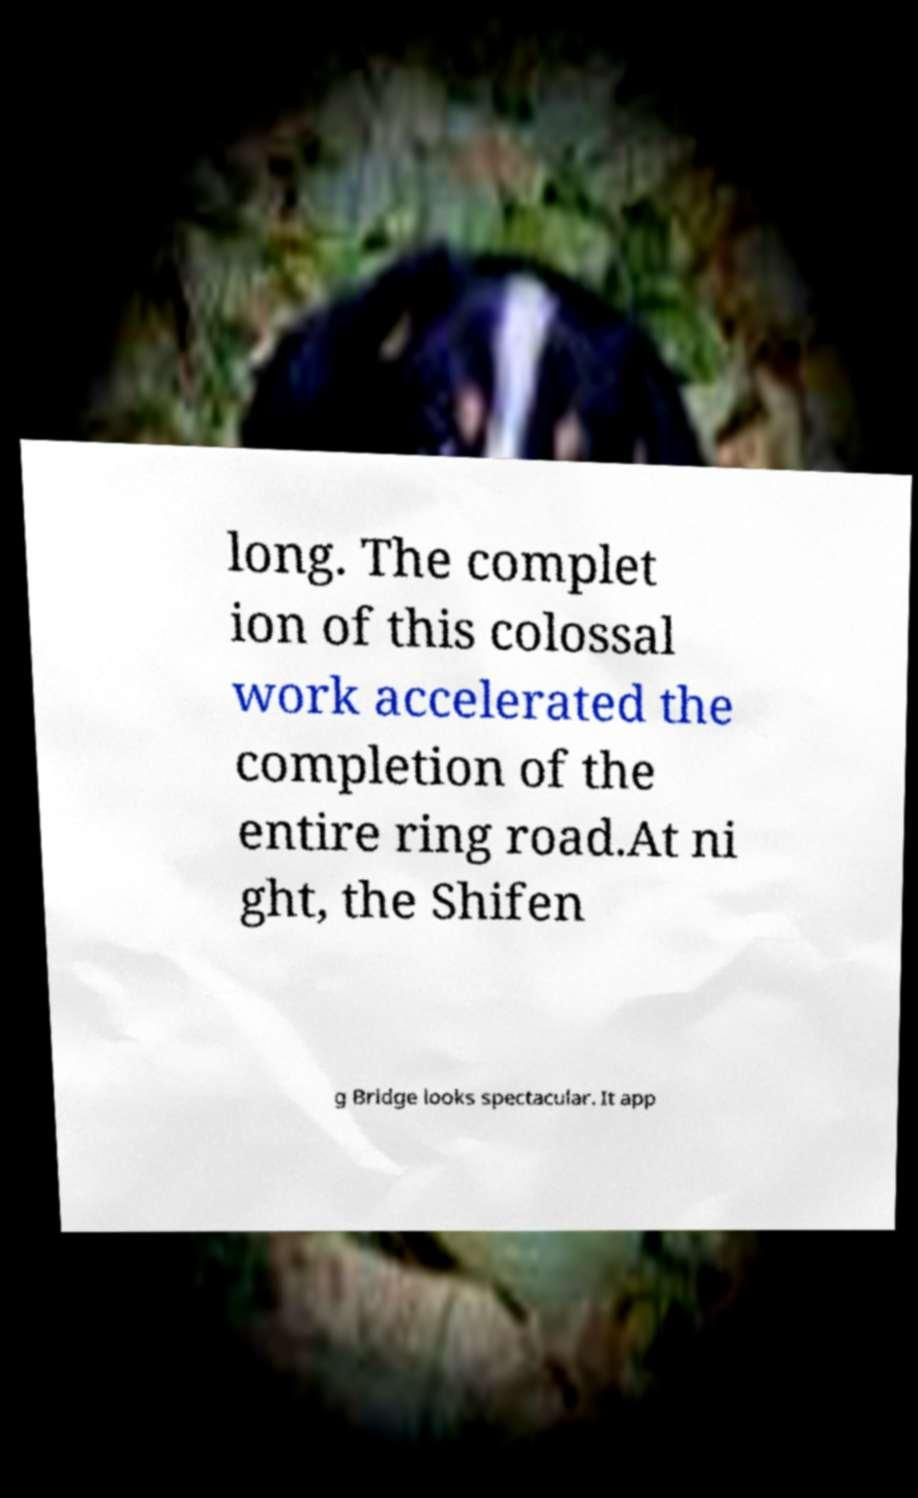I need the written content from this picture converted into text. Can you do that? long. The complet ion of this colossal work accelerated the completion of the entire ring road.At ni ght, the Shifen g Bridge looks spectacular. It app 